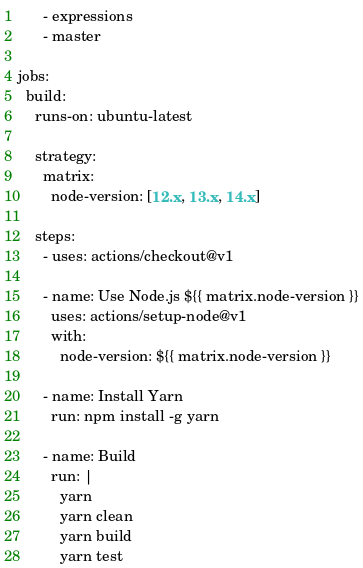<code> <loc_0><loc_0><loc_500><loc_500><_YAML_>      - expressions
      - master

jobs:
  build:
    runs-on: ubuntu-latest

    strategy:
      matrix:
        node-version: [12.x, 13.x, 14.x]

    steps:
      - uses: actions/checkout@v1

      - name: Use Node.js ${{ matrix.node-version }}
        uses: actions/setup-node@v1
        with:
          node-version: ${{ matrix.node-version }}

      - name: Install Yarn
        run: npm install -g yarn

      - name: Build
        run: |
          yarn
          yarn clean
          yarn build
          yarn test
</code> 